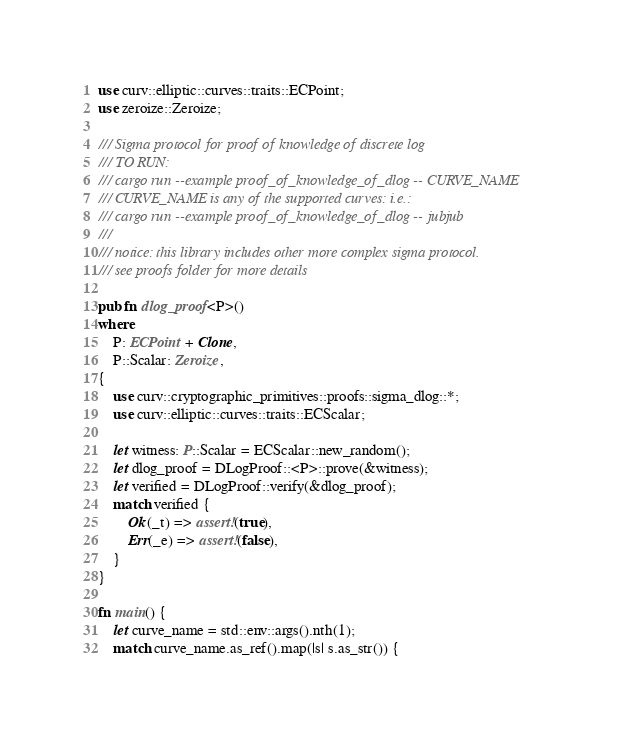Convert code to text. <code><loc_0><loc_0><loc_500><loc_500><_Rust_>use curv::elliptic::curves::traits::ECPoint;
use zeroize::Zeroize;

/// Sigma protocol for proof of knowledge of discrete log
/// TO RUN:
/// cargo run --example proof_of_knowledge_of_dlog -- CURVE_NAME
/// CURVE_NAME is any of the supported curves: i.e.:
/// cargo run --example proof_of_knowledge_of_dlog -- jubjub
///
/// notice: this library includes other more complex sigma protocol.
/// see proofs folder for more details

pub fn dlog_proof<P>()
where
    P: ECPoint + Clone,
    P::Scalar: Zeroize,
{
    use curv::cryptographic_primitives::proofs::sigma_dlog::*;
    use curv::elliptic::curves::traits::ECScalar;

    let witness: P::Scalar = ECScalar::new_random();
    let dlog_proof = DLogProof::<P>::prove(&witness);
    let verified = DLogProof::verify(&dlog_proof);
    match verified {
        Ok(_t) => assert!(true),
        Err(_e) => assert!(false),
    }
}

fn main() {
    let curve_name = std::env::args().nth(1);
    match curve_name.as_ref().map(|s| s.as_str()) {</code> 